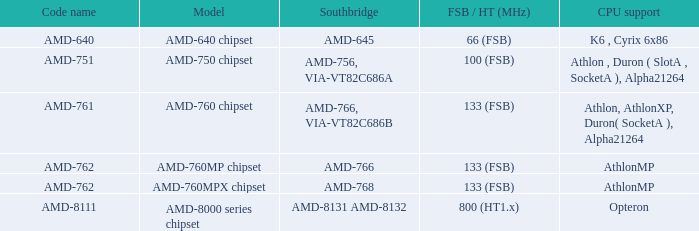What is the code name when the FSB / HT (MHz) is 100 (fsb)? AMD-751. 